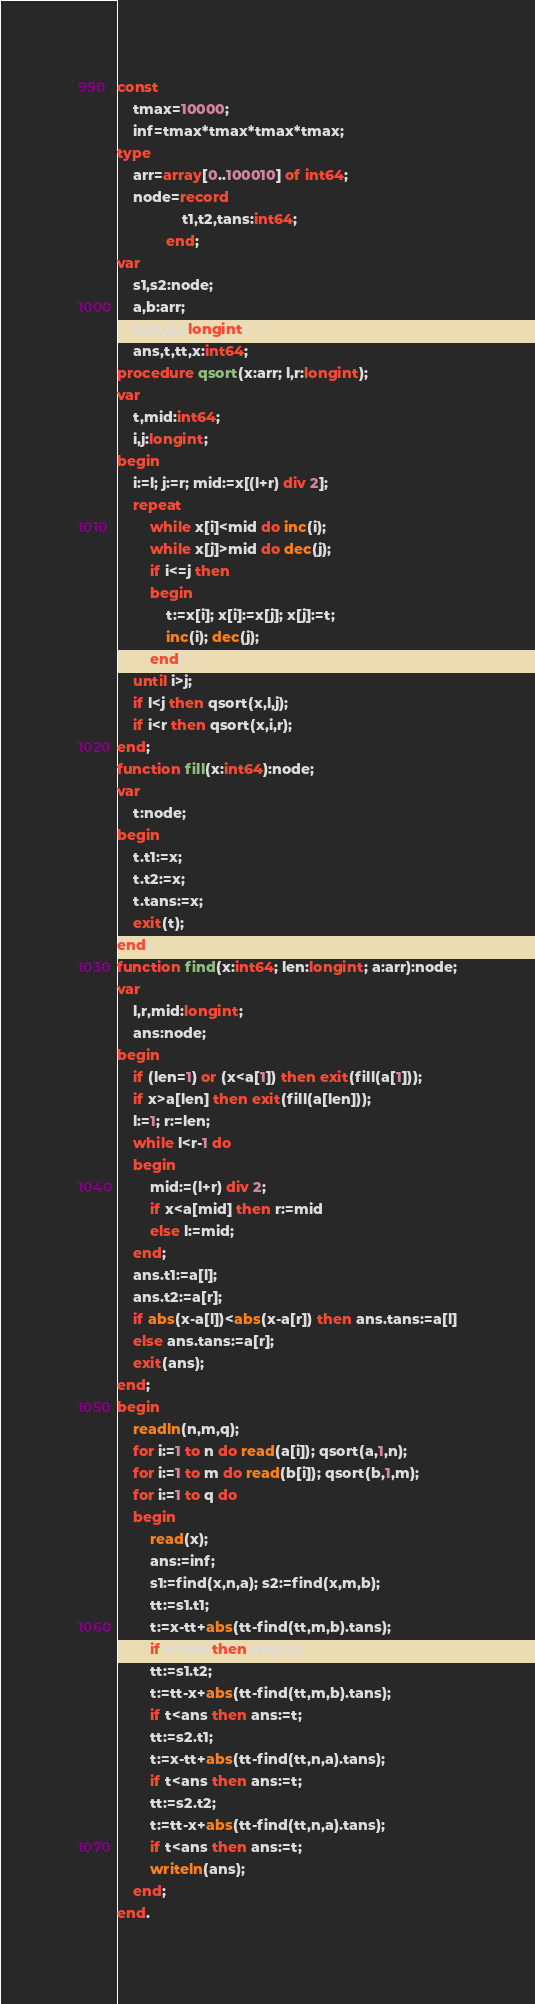<code> <loc_0><loc_0><loc_500><loc_500><_Pascal_>const
	tmax=10000;
	inf=tmax*tmax*tmax*tmax;
type
	arr=array[0..100010] of int64;
	node=record
				t1,t2,tans:int64;
			end;
var
	s1,s2:node;
	a,b:arr;
	n,m,q,i:longint;
	ans,t,tt,x:int64;
procedure qsort(x:arr; l,r:longint);
var
	t,mid:int64;
	i,j:longint;
begin
	i:=l; j:=r; mid:=x[(l+r) div 2];
	repeat
		while x[i]<mid do inc(i);
		while x[j]>mid do dec(j);
		if i<=j then
		begin
			t:=x[i]; x[i]:=x[j]; x[j]:=t;
			inc(i); dec(j);
		end;
	until i>j;
	if l<j then qsort(x,l,j);
	if i<r then qsort(x,i,r);
end;
function fill(x:int64):node;
var
	t:node;
begin
	t.t1:=x;
	t.t2:=x;
	t.tans:=x;
	exit(t);
end;
function find(x:int64; len:longint; a:arr):node;
var
	l,r,mid:longint;
	ans:node;
begin
	if (len=1) or (x<a[1]) then exit(fill(a[1]));
	if x>a[len] then exit(fill(a[len]));
	l:=1; r:=len;
	while l<r-1 do
	begin
		mid:=(l+r) div 2;
		if x<a[mid] then r:=mid
		else l:=mid;
	end;
	ans.t1:=a[l];
	ans.t2:=a[r];
	if abs(x-a[l])<abs(x-a[r]) then ans.tans:=a[l]
	else ans.tans:=a[r];
	exit(ans);
end;
begin
	readln(n,m,q);
	for i:=1 to n do read(a[i]); qsort(a,1,n);
	for i:=1 to m do read(b[i]); qsort(b,1,m);
	for i:=1 to q do
	begin
		read(x);
		ans:=inf;
		s1:=find(x,n,a); s2:=find(x,m,b);
		tt:=s1.t1;
		t:=x-tt+abs(tt-find(tt,m,b).tans);
		if t<ans then ans:=t;
		tt:=s1.t2;
		t:=tt-x+abs(tt-find(tt,m,b).tans);
		if t<ans then ans:=t;
		tt:=s2.t1;
		t:=x-tt+abs(tt-find(tt,n,a).tans);
		if t<ans then ans:=t;
		tt:=s2.t2;
		t:=tt-x+abs(tt-find(tt,n,a).tans);
		if t<ans then ans:=t;
		writeln(ans);
	end;
end.</code> 